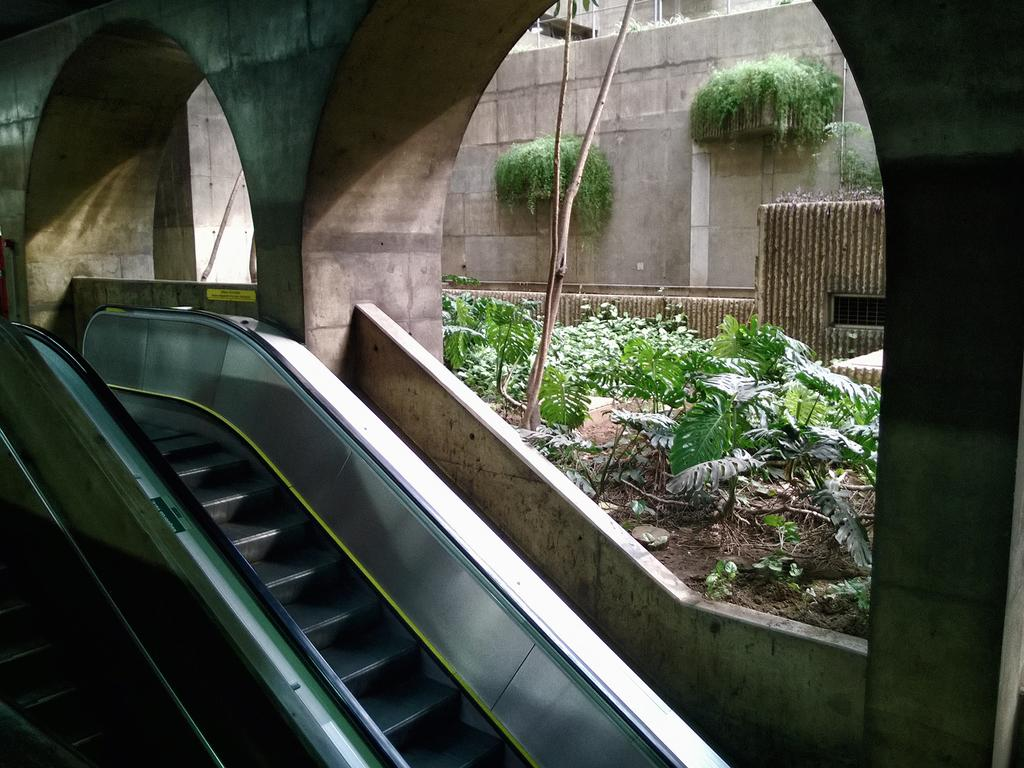What is the main subject in the center of the image? There is an escalator in the center of the image. What can be seen in the background of the image? There are plants, pillars, a wall, and a building in the background of the image. What type of pets can be seen holding onto the escalator in the image? There are no pets present in the image, and therefore no pets can be seen holding onto the escalator. 